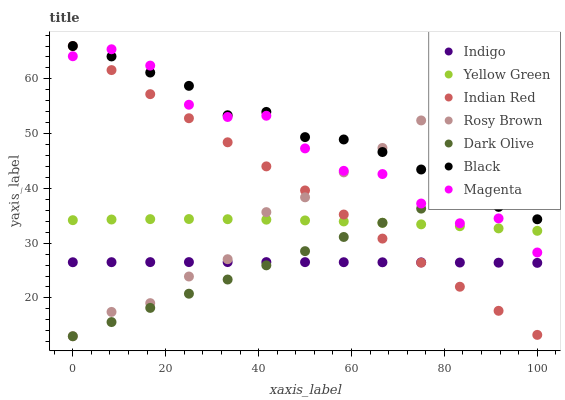Does Indigo have the minimum area under the curve?
Answer yes or no. Yes. Does Black have the maximum area under the curve?
Answer yes or no. Yes. Does Yellow Green have the minimum area under the curve?
Answer yes or no. No. Does Yellow Green have the maximum area under the curve?
Answer yes or no. No. Is Indian Red the smoothest?
Answer yes or no. Yes. Is Magenta the roughest?
Answer yes or no. Yes. Is Indigo the smoothest?
Answer yes or no. No. Is Indigo the roughest?
Answer yes or no. No. Does Rosy Brown have the lowest value?
Answer yes or no. Yes. Does Indigo have the lowest value?
Answer yes or no. No. Does Indian Red have the highest value?
Answer yes or no. Yes. Does Yellow Green have the highest value?
Answer yes or no. No. Is Indigo less than Magenta?
Answer yes or no. Yes. Is Magenta greater than Indigo?
Answer yes or no. Yes. Does Indian Red intersect Black?
Answer yes or no. Yes. Is Indian Red less than Black?
Answer yes or no. No. Is Indian Red greater than Black?
Answer yes or no. No. Does Indigo intersect Magenta?
Answer yes or no. No. 